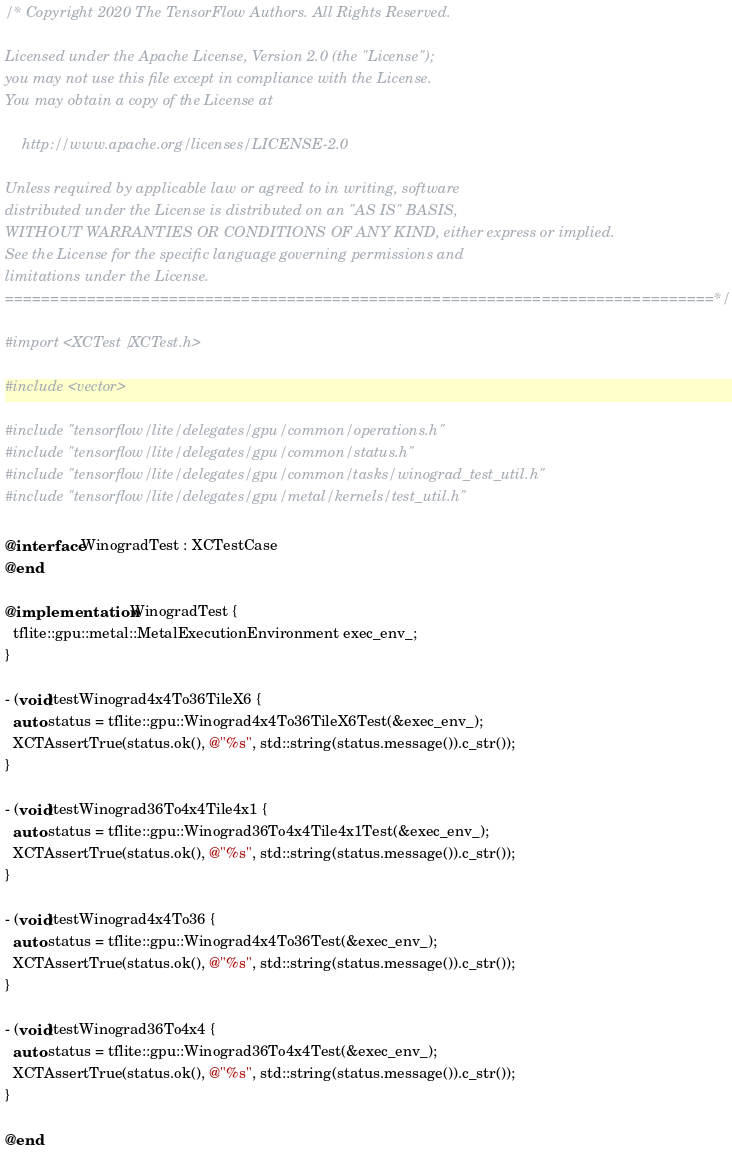Convert code to text. <code><loc_0><loc_0><loc_500><loc_500><_ObjectiveC_>/* Copyright 2020 The TensorFlow Authors. All Rights Reserved.

Licensed under the Apache License, Version 2.0 (the "License");
you may not use this file except in compliance with the License.
You may obtain a copy of the License at

    http://www.apache.org/licenses/LICENSE-2.0

Unless required by applicable law or agreed to in writing, software
distributed under the License is distributed on an "AS IS" BASIS,
WITHOUT WARRANTIES OR CONDITIONS OF ANY KIND, either express or implied.
See the License for the specific language governing permissions and
limitations under the License.
==============================================================================*/

#import <XCTest/XCTest.h>

#include <vector>

#include "tensorflow/lite/delegates/gpu/common/operations.h"
#include "tensorflow/lite/delegates/gpu/common/status.h"
#include "tensorflow/lite/delegates/gpu/common/tasks/winograd_test_util.h"
#include "tensorflow/lite/delegates/gpu/metal/kernels/test_util.h"

@interface WinogradTest : XCTestCase
@end

@implementation WinogradTest {
  tflite::gpu::metal::MetalExecutionEnvironment exec_env_;
}

- (void)testWinograd4x4To36TileX6 {
  auto status = tflite::gpu::Winograd4x4To36TileX6Test(&exec_env_);
  XCTAssertTrue(status.ok(), @"%s", std::string(status.message()).c_str());
}

- (void)testWinograd36To4x4Tile4x1 {
  auto status = tflite::gpu::Winograd36To4x4Tile4x1Test(&exec_env_);
  XCTAssertTrue(status.ok(), @"%s", std::string(status.message()).c_str());
}

- (void)testWinograd4x4To36 {
  auto status = tflite::gpu::Winograd4x4To36Test(&exec_env_);
  XCTAssertTrue(status.ok(), @"%s", std::string(status.message()).c_str());
}

- (void)testWinograd36To4x4 {
  auto status = tflite::gpu::Winograd36To4x4Test(&exec_env_);
  XCTAssertTrue(status.ok(), @"%s", std::string(status.message()).c_str());
}

@end
</code> 